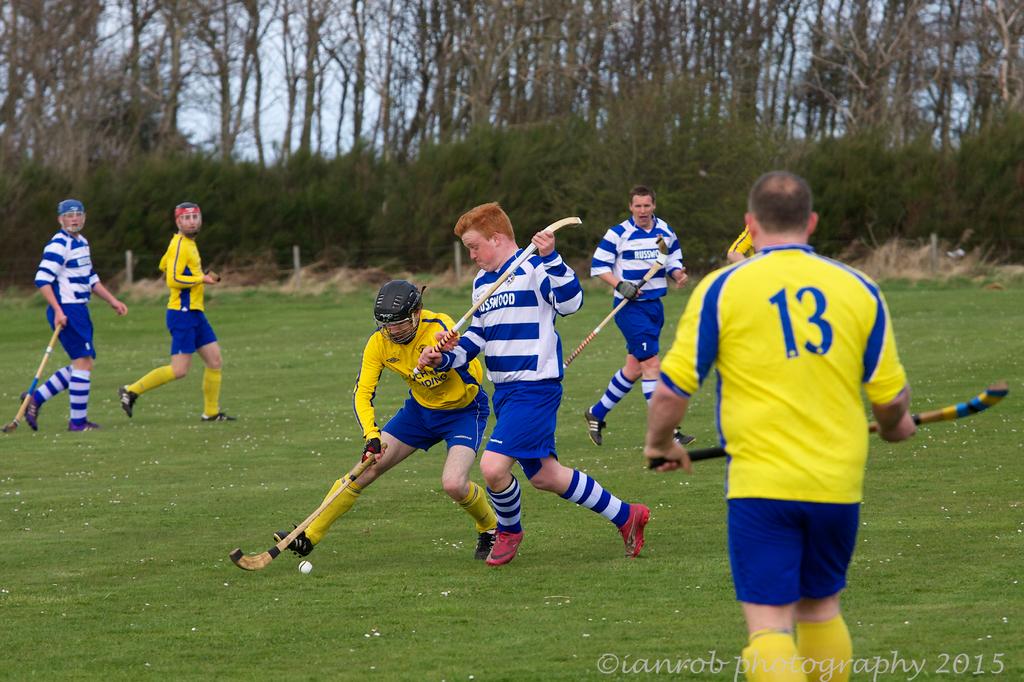What number is on the man in yellow jersey?
Your response must be concise. 13. The color of the numbers 13 is?
Offer a very short reply. Blue. 